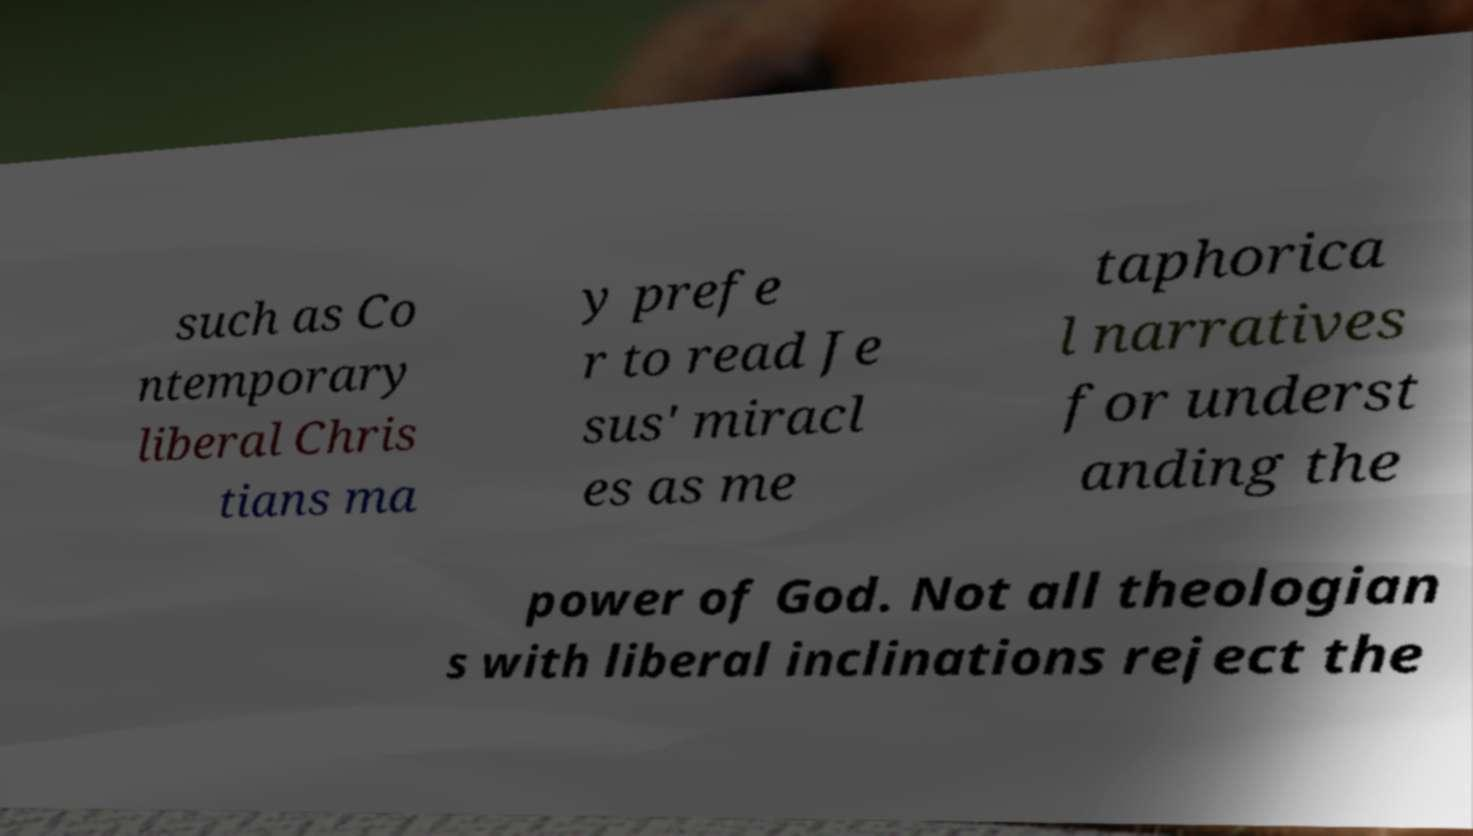I need the written content from this picture converted into text. Can you do that? such as Co ntemporary liberal Chris tians ma y prefe r to read Je sus' miracl es as me taphorica l narratives for underst anding the power of God. Not all theologian s with liberal inclinations reject the 